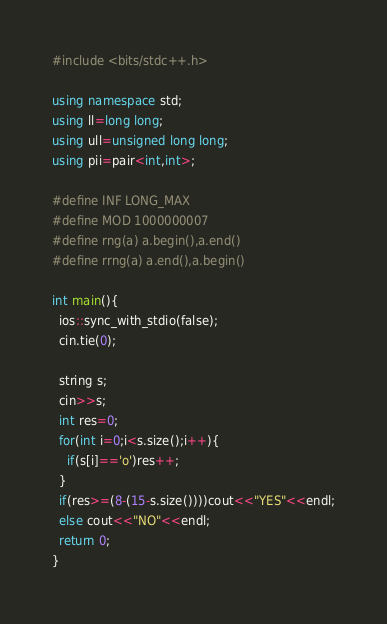<code> <loc_0><loc_0><loc_500><loc_500><_C++_>#include <bits/stdc++.h> 

using namespace std;
using ll=long long;
using ull=unsigned long long;
using pii=pair<int,int>;

#define INF LONG_MAX
#define MOD 1000000007
#define rng(a) a.begin(),a.end()
#define rrng(a) a.end(),a.begin()

int main(){
  ios::sync_with_stdio(false);
  cin.tie(0);

  string s;
  cin>>s;
  int res=0;
  for(int i=0;i<s.size();i++){
    if(s[i]=='o')res++;
  }
  if(res>=(8-(15-s.size())))cout<<"YES"<<endl;
  else cout<<"NO"<<endl;
  return 0;
}
</code> 